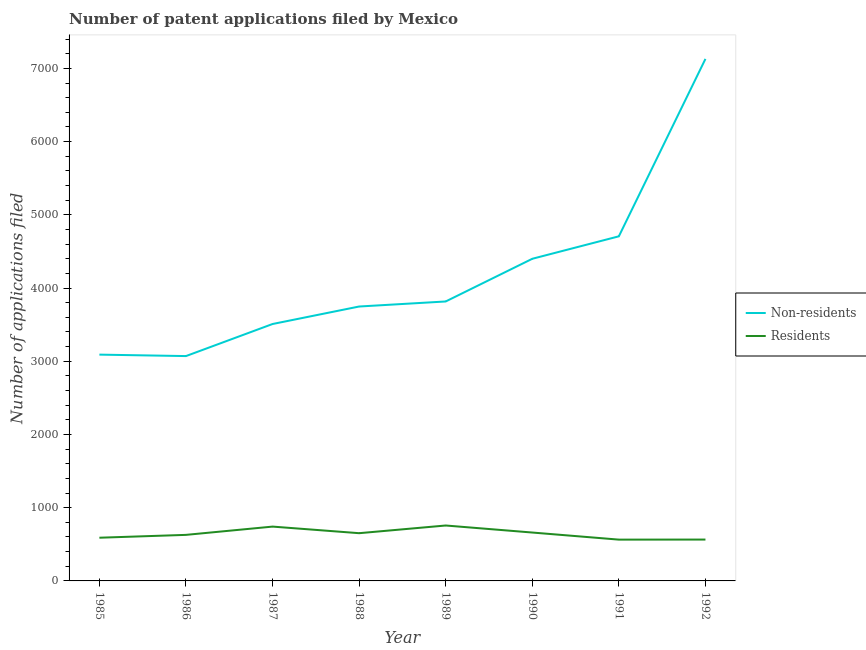How many different coloured lines are there?
Keep it short and to the point. 2. What is the number of patent applications by non residents in 1987?
Your response must be concise. 3509. Across all years, what is the maximum number of patent applications by residents?
Offer a very short reply. 757. Across all years, what is the minimum number of patent applications by residents?
Offer a very short reply. 564. What is the total number of patent applications by non residents in the graph?
Offer a terse response. 3.35e+04. What is the difference between the number of patent applications by residents in 1987 and that in 1990?
Your answer should be very brief. 81. What is the difference between the number of patent applications by non residents in 1990 and the number of patent applications by residents in 1988?
Your answer should be very brief. 3748. What is the average number of patent applications by residents per year?
Your answer should be very brief. 645. In the year 1986, what is the difference between the number of patent applications by non residents and number of patent applications by residents?
Your answer should be compact. 2442. What is the ratio of the number of patent applications by non residents in 1986 to that in 1990?
Your response must be concise. 0.7. Is the number of patent applications by residents in 1989 less than that in 1990?
Give a very brief answer. No. What is the difference between the highest and the second highest number of patent applications by residents?
Keep it short and to the point. 15. What is the difference between the highest and the lowest number of patent applications by residents?
Provide a succinct answer. 193. Is the sum of the number of patent applications by residents in 1985 and 1987 greater than the maximum number of patent applications by non residents across all years?
Ensure brevity in your answer.  No. Does the number of patent applications by non residents monotonically increase over the years?
Your answer should be very brief. No. Is the number of patent applications by non residents strictly less than the number of patent applications by residents over the years?
Offer a very short reply. No. How many years are there in the graph?
Your answer should be very brief. 8. Are the values on the major ticks of Y-axis written in scientific E-notation?
Your response must be concise. No. Does the graph contain grids?
Provide a short and direct response. No. How are the legend labels stacked?
Provide a short and direct response. Vertical. What is the title of the graph?
Make the answer very short. Number of patent applications filed by Mexico. What is the label or title of the Y-axis?
Ensure brevity in your answer.  Number of applications filed. What is the Number of applications filed in Non-residents in 1985?
Provide a succinct answer. 3091. What is the Number of applications filed in Residents in 1985?
Ensure brevity in your answer.  590. What is the Number of applications filed in Non-residents in 1986?
Ensure brevity in your answer.  3071. What is the Number of applications filed in Residents in 1986?
Provide a short and direct response. 629. What is the Number of applications filed of Non-residents in 1987?
Your response must be concise. 3509. What is the Number of applications filed of Residents in 1987?
Offer a terse response. 742. What is the Number of applications filed in Non-residents in 1988?
Ensure brevity in your answer.  3748. What is the Number of applications filed in Residents in 1988?
Make the answer very short. 652. What is the Number of applications filed in Non-residents in 1989?
Your response must be concise. 3817. What is the Number of applications filed of Residents in 1989?
Your answer should be compact. 757. What is the Number of applications filed in Non-residents in 1990?
Your response must be concise. 4400. What is the Number of applications filed of Residents in 1990?
Provide a succinct answer. 661. What is the Number of applications filed in Non-residents in 1991?
Ensure brevity in your answer.  4707. What is the Number of applications filed of Residents in 1991?
Keep it short and to the point. 564. What is the Number of applications filed in Non-residents in 1992?
Your answer should be compact. 7130. What is the Number of applications filed of Residents in 1992?
Offer a terse response. 565. Across all years, what is the maximum Number of applications filed in Non-residents?
Give a very brief answer. 7130. Across all years, what is the maximum Number of applications filed of Residents?
Give a very brief answer. 757. Across all years, what is the minimum Number of applications filed of Non-residents?
Provide a short and direct response. 3071. Across all years, what is the minimum Number of applications filed of Residents?
Give a very brief answer. 564. What is the total Number of applications filed in Non-residents in the graph?
Make the answer very short. 3.35e+04. What is the total Number of applications filed of Residents in the graph?
Make the answer very short. 5160. What is the difference between the Number of applications filed in Non-residents in 1985 and that in 1986?
Your response must be concise. 20. What is the difference between the Number of applications filed in Residents in 1985 and that in 1986?
Your answer should be very brief. -39. What is the difference between the Number of applications filed of Non-residents in 1985 and that in 1987?
Provide a succinct answer. -418. What is the difference between the Number of applications filed in Residents in 1985 and that in 1987?
Your answer should be very brief. -152. What is the difference between the Number of applications filed of Non-residents in 1985 and that in 1988?
Give a very brief answer. -657. What is the difference between the Number of applications filed of Residents in 1985 and that in 1988?
Provide a succinct answer. -62. What is the difference between the Number of applications filed of Non-residents in 1985 and that in 1989?
Your answer should be very brief. -726. What is the difference between the Number of applications filed of Residents in 1985 and that in 1989?
Ensure brevity in your answer.  -167. What is the difference between the Number of applications filed in Non-residents in 1985 and that in 1990?
Offer a terse response. -1309. What is the difference between the Number of applications filed of Residents in 1985 and that in 1990?
Your answer should be very brief. -71. What is the difference between the Number of applications filed in Non-residents in 1985 and that in 1991?
Ensure brevity in your answer.  -1616. What is the difference between the Number of applications filed in Non-residents in 1985 and that in 1992?
Offer a very short reply. -4039. What is the difference between the Number of applications filed of Non-residents in 1986 and that in 1987?
Provide a short and direct response. -438. What is the difference between the Number of applications filed in Residents in 1986 and that in 1987?
Provide a succinct answer. -113. What is the difference between the Number of applications filed of Non-residents in 1986 and that in 1988?
Ensure brevity in your answer.  -677. What is the difference between the Number of applications filed of Non-residents in 1986 and that in 1989?
Offer a very short reply. -746. What is the difference between the Number of applications filed of Residents in 1986 and that in 1989?
Your answer should be compact. -128. What is the difference between the Number of applications filed in Non-residents in 1986 and that in 1990?
Provide a short and direct response. -1329. What is the difference between the Number of applications filed in Residents in 1986 and that in 1990?
Provide a succinct answer. -32. What is the difference between the Number of applications filed in Non-residents in 1986 and that in 1991?
Ensure brevity in your answer.  -1636. What is the difference between the Number of applications filed of Residents in 1986 and that in 1991?
Your response must be concise. 65. What is the difference between the Number of applications filed in Non-residents in 1986 and that in 1992?
Give a very brief answer. -4059. What is the difference between the Number of applications filed of Non-residents in 1987 and that in 1988?
Give a very brief answer. -239. What is the difference between the Number of applications filed in Residents in 1987 and that in 1988?
Your answer should be compact. 90. What is the difference between the Number of applications filed in Non-residents in 1987 and that in 1989?
Offer a terse response. -308. What is the difference between the Number of applications filed of Residents in 1987 and that in 1989?
Make the answer very short. -15. What is the difference between the Number of applications filed of Non-residents in 1987 and that in 1990?
Ensure brevity in your answer.  -891. What is the difference between the Number of applications filed of Residents in 1987 and that in 1990?
Provide a short and direct response. 81. What is the difference between the Number of applications filed of Non-residents in 1987 and that in 1991?
Make the answer very short. -1198. What is the difference between the Number of applications filed of Residents in 1987 and that in 1991?
Your answer should be very brief. 178. What is the difference between the Number of applications filed in Non-residents in 1987 and that in 1992?
Keep it short and to the point. -3621. What is the difference between the Number of applications filed of Residents in 1987 and that in 1992?
Your answer should be compact. 177. What is the difference between the Number of applications filed in Non-residents in 1988 and that in 1989?
Provide a short and direct response. -69. What is the difference between the Number of applications filed in Residents in 1988 and that in 1989?
Your response must be concise. -105. What is the difference between the Number of applications filed in Non-residents in 1988 and that in 1990?
Offer a terse response. -652. What is the difference between the Number of applications filed of Non-residents in 1988 and that in 1991?
Your response must be concise. -959. What is the difference between the Number of applications filed in Non-residents in 1988 and that in 1992?
Your answer should be compact. -3382. What is the difference between the Number of applications filed in Residents in 1988 and that in 1992?
Give a very brief answer. 87. What is the difference between the Number of applications filed in Non-residents in 1989 and that in 1990?
Ensure brevity in your answer.  -583. What is the difference between the Number of applications filed of Residents in 1989 and that in 1990?
Make the answer very short. 96. What is the difference between the Number of applications filed of Non-residents in 1989 and that in 1991?
Offer a terse response. -890. What is the difference between the Number of applications filed of Residents in 1989 and that in 1991?
Make the answer very short. 193. What is the difference between the Number of applications filed in Non-residents in 1989 and that in 1992?
Keep it short and to the point. -3313. What is the difference between the Number of applications filed in Residents in 1989 and that in 1992?
Offer a very short reply. 192. What is the difference between the Number of applications filed of Non-residents in 1990 and that in 1991?
Offer a very short reply. -307. What is the difference between the Number of applications filed in Residents in 1990 and that in 1991?
Make the answer very short. 97. What is the difference between the Number of applications filed in Non-residents in 1990 and that in 1992?
Your response must be concise. -2730. What is the difference between the Number of applications filed of Residents in 1990 and that in 1992?
Make the answer very short. 96. What is the difference between the Number of applications filed in Non-residents in 1991 and that in 1992?
Keep it short and to the point. -2423. What is the difference between the Number of applications filed of Residents in 1991 and that in 1992?
Ensure brevity in your answer.  -1. What is the difference between the Number of applications filed in Non-residents in 1985 and the Number of applications filed in Residents in 1986?
Provide a short and direct response. 2462. What is the difference between the Number of applications filed of Non-residents in 1985 and the Number of applications filed of Residents in 1987?
Offer a very short reply. 2349. What is the difference between the Number of applications filed of Non-residents in 1985 and the Number of applications filed of Residents in 1988?
Your response must be concise. 2439. What is the difference between the Number of applications filed in Non-residents in 1985 and the Number of applications filed in Residents in 1989?
Provide a short and direct response. 2334. What is the difference between the Number of applications filed in Non-residents in 1985 and the Number of applications filed in Residents in 1990?
Offer a terse response. 2430. What is the difference between the Number of applications filed in Non-residents in 1985 and the Number of applications filed in Residents in 1991?
Keep it short and to the point. 2527. What is the difference between the Number of applications filed of Non-residents in 1985 and the Number of applications filed of Residents in 1992?
Make the answer very short. 2526. What is the difference between the Number of applications filed in Non-residents in 1986 and the Number of applications filed in Residents in 1987?
Your response must be concise. 2329. What is the difference between the Number of applications filed in Non-residents in 1986 and the Number of applications filed in Residents in 1988?
Keep it short and to the point. 2419. What is the difference between the Number of applications filed in Non-residents in 1986 and the Number of applications filed in Residents in 1989?
Offer a terse response. 2314. What is the difference between the Number of applications filed of Non-residents in 1986 and the Number of applications filed of Residents in 1990?
Offer a very short reply. 2410. What is the difference between the Number of applications filed of Non-residents in 1986 and the Number of applications filed of Residents in 1991?
Keep it short and to the point. 2507. What is the difference between the Number of applications filed in Non-residents in 1986 and the Number of applications filed in Residents in 1992?
Ensure brevity in your answer.  2506. What is the difference between the Number of applications filed of Non-residents in 1987 and the Number of applications filed of Residents in 1988?
Make the answer very short. 2857. What is the difference between the Number of applications filed in Non-residents in 1987 and the Number of applications filed in Residents in 1989?
Provide a succinct answer. 2752. What is the difference between the Number of applications filed in Non-residents in 1987 and the Number of applications filed in Residents in 1990?
Your answer should be compact. 2848. What is the difference between the Number of applications filed in Non-residents in 1987 and the Number of applications filed in Residents in 1991?
Provide a succinct answer. 2945. What is the difference between the Number of applications filed of Non-residents in 1987 and the Number of applications filed of Residents in 1992?
Make the answer very short. 2944. What is the difference between the Number of applications filed in Non-residents in 1988 and the Number of applications filed in Residents in 1989?
Offer a very short reply. 2991. What is the difference between the Number of applications filed in Non-residents in 1988 and the Number of applications filed in Residents in 1990?
Your answer should be very brief. 3087. What is the difference between the Number of applications filed of Non-residents in 1988 and the Number of applications filed of Residents in 1991?
Your answer should be compact. 3184. What is the difference between the Number of applications filed of Non-residents in 1988 and the Number of applications filed of Residents in 1992?
Keep it short and to the point. 3183. What is the difference between the Number of applications filed of Non-residents in 1989 and the Number of applications filed of Residents in 1990?
Offer a very short reply. 3156. What is the difference between the Number of applications filed in Non-residents in 1989 and the Number of applications filed in Residents in 1991?
Offer a very short reply. 3253. What is the difference between the Number of applications filed in Non-residents in 1989 and the Number of applications filed in Residents in 1992?
Offer a very short reply. 3252. What is the difference between the Number of applications filed in Non-residents in 1990 and the Number of applications filed in Residents in 1991?
Provide a succinct answer. 3836. What is the difference between the Number of applications filed of Non-residents in 1990 and the Number of applications filed of Residents in 1992?
Your answer should be compact. 3835. What is the difference between the Number of applications filed of Non-residents in 1991 and the Number of applications filed of Residents in 1992?
Offer a terse response. 4142. What is the average Number of applications filed in Non-residents per year?
Give a very brief answer. 4184.12. What is the average Number of applications filed of Residents per year?
Offer a terse response. 645. In the year 1985, what is the difference between the Number of applications filed of Non-residents and Number of applications filed of Residents?
Offer a terse response. 2501. In the year 1986, what is the difference between the Number of applications filed in Non-residents and Number of applications filed in Residents?
Offer a terse response. 2442. In the year 1987, what is the difference between the Number of applications filed in Non-residents and Number of applications filed in Residents?
Ensure brevity in your answer.  2767. In the year 1988, what is the difference between the Number of applications filed of Non-residents and Number of applications filed of Residents?
Your answer should be very brief. 3096. In the year 1989, what is the difference between the Number of applications filed of Non-residents and Number of applications filed of Residents?
Offer a terse response. 3060. In the year 1990, what is the difference between the Number of applications filed in Non-residents and Number of applications filed in Residents?
Provide a succinct answer. 3739. In the year 1991, what is the difference between the Number of applications filed in Non-residents and Number of applications filed in Residents?
Make the answer very short. 4143. In the year 1992, what is the difference between the Number of applications filed of Non-residents and Number of applications filed of Residents?
Keep it short and to the point. 6565. What is the ratio of the Number of applications filed in Residents in 1985 to that in 1986?
Keep it short and to the point. 0.94. What is the ratio of the Number of applications filed in Non-residents in 1985 to that in 1987?
Offer a terse response. 0.88. What is the ratio of the Number of applications filed in Residents in 1985 to that in 1987?
Provide a succinct answer. 0.8. What is the ratio of the Number of applications filed in Non-residents in 1985 to that in 1988?
Offer a terse response. 0.82. What is the ratio of the Number of applications filed of Residents in 1985 to that in 1988?
Your answer should be compact. 0.9. What is the ratio of the Number of applications filed of Non-residents in 1985 to that in 1989?
Provide a short and direct response. 0.81. What is the ratio of the Number of applications filed of Residents in 1985 to that in 1989?
Provide a succinct answer. 0.78. What is the ratio of the Number of applications filed of Non-residents in 1985 to that in 1990?
Ensure brevity in your answer.  0.7. What is the ratio of the Number of applications filed of Residents in 1985 to that in 1990?
Your response must be concise. 0.89. What is the ratio of the Number of applications filed of Non-residents in 1985 to that in 1991?
Offer a very short reply. 0.66. What is the ratio of the Number of applications filed of Residents in 1985 to that in 1991?
Your answer should be compact. 1.05. What is the ratio of the Number of applications filed of Non-residents in 1985 to that in 1992?
Provide a short and direct response. 0.43. What is the ratio of the Number of applications filed in Residents in 1985 to that in 1992?
Your answer should be very brief. 1.04. What is the ratio of the Number of applications filed of Non-residents in 1986 to that in 1987?
Your answer should be compact. 0.88. What is the ratio of the Number of applications filed of Residents in 1986 to that in 1987?
Give a very brief answer. 0.85. What is the ratio of the Number of applications filed in Non-residents in 1986 to that in 1988?
Make the answer very short. 0.82. What is the ratio of the Number of applications filed of Residents in 1986 to that in 1988?
Your answer should be compact. 0.96. What is the ratio of the Number of applications filed of Non-residents in 1986 to that in 1989?
Your answer should be very brief. 0.8. What is the ratio of the Number of applications filed of Residents in 1986 to that in 1989?
Offer a terse response. 0.83. What is the ratio of the Number of applications filed in Non-residents in 1986 to that in 1990?
Offer a terse response. 0.7. What is the ratio of the Number of applications filed of Residents in 1986 to that in 1990?
Provide a short and direct response. 0.95. What is the ratio of the Number of applications filed of Non-residents in 1986 to that in 1991?
Offer a terse response. 0.65. What is the ratio of the Number of applications filed of Residents in 1986 to that in 1991?
Provide a succinct answer. 1.12. What is the ratio of the Number of applications filed of Non-residents in 1986 to that in 1992?
Your answer should be very brief. 0.43. What is the ratio of the Number of applications filed in Residents in 1986 to that in 1992?
Provide a short and direct response. 1.11. What is the ratio of the Number of applications filed in Non-residents in 1987 to that in 1988?
Ensure brevity in your answer.  0.94. What is the ratio of the Number of applications filed in Residents in 1987 to that in 1988?
Offer a terse response. 1.14. What is the ratio of the Number of applications filed in Non-residents in 1987 to that in 1989?
Make the answer very short. 0.92. What is the ratio of the Number of applications filed in Residents in 1987 to that in 1989?
Your response must be concise. 0.98. What is the ratio of the Number of applications filed in Non-residents in 1987 to that in 1990?
Provide a succinct answer. 0.8. What is the ratio of the Number of applications filed in Residents in 1987 to that in 1990?
Provide a succinct answer. 1.12. What is the ratio of the Number of applications filed of Non-residents in 1987 to that in 1991?
Offer a very short reply. 0.75. What is the ratio of the Number of applications filed of Residents in 1987 to that in 1991?
Your answer should be very brief. 1.32. What is the ratio of the Number of applications filed of Non-residents in 1987 to that in 1992?
Your response must be concise. 0.49. What is the ratio of the Number of applications filed in Residents in 1987 to that in 1992?
Provide a short and direct response. 1.31. What is the ratio of the Number of applications filed of Non-residents in 1988 to that in 1989?
Offer a terse response. 0.98. What is the ratio of the Number of applications filed of Residents in 1988 to that in 1989?
Offer a terse response. 0.86. What is the ratio of the Number of applications filed of Non-residents in 1988 to that in 1990?
Offer a very short reply. 0.85. What is the ratio of the Number of applications filed in Residents in 1988 to that in 1990?
Your response must be concise. 0.99. What is the ratio of the Number of applications filed in Non-residents in 1988 to that in 1991?
Your answer should be compact. 0.8. What is the ratio of the Number of applications filed in Residents in 1988 to that in 1991?
Your response must be concise. 1.16. What is the ratio of the Number of applications filed of Non-residents in 1988 to that in 1992?
Give a very brief answer. 0.53. What is the ratio of the Number of applications filed of Residents in 1988 to that in 1992?
Offer a terse response. 1.15. What is the ratio of the Number of applications filed in Non-residents in 1989 to that in 1990?
Offer a terse response. 0.87. What is the ratio of the Number of applications filed in Residents in 1989 to that in 1990?
Provide a short and direct response. 1.15. What is the ratio of the Number of applications filed of Non-residents in 1989 to that in 1991?
Your answer should be very brief. 0.81. What is the ratio of the Number of applications filed in Residents in 1989 to that in 1991?
Keep it short and to the point. 1.34. What is the ratio of the Number of applications filed in Non-residents in 1989 to that in 1992?
Your answer should be compact. 0.54. What is the ratio of the Number of applications filed in Residents in 1989 to that in 1992?
Offer a very short reply. 1.34. What is the ratio of the Number of applications filed in Non-residents in 1990 to that in 1991?
Make the answer very short. 0.93. What is the ratio of the Number of applications filed in Residents in 1990 to that in 1991?
Offer a very short reply. 1.17. What is the ratio of the Number of applications filed of Non-residents in 1990 to that in 1992?
Make the answer very short. 0.62. What is the ratio of the Number of applications filed of Residents in 1990 to that in 1992?
Provide a short and direct response. 1.17. What is the ratio of the Number of applications filed in Non-residents in 1991 to that in 1992?
Your answer should be compact. 0.66. What is the difference between the highest and the second highest Number of applications filed of Non-residents?
Your answer should be compact. 2423. What is the difference between the highest and the second highest Number of applications filed in Residents?
Offer a terse response. 15. What is the difference between the highest and the lowest Number of applications filed in Non-residents?
Ensure brevity in your answer.  4059. What is the difference between the highest and the lowest Number of applications filed of Residents?
Your answer should be compact. 193. 